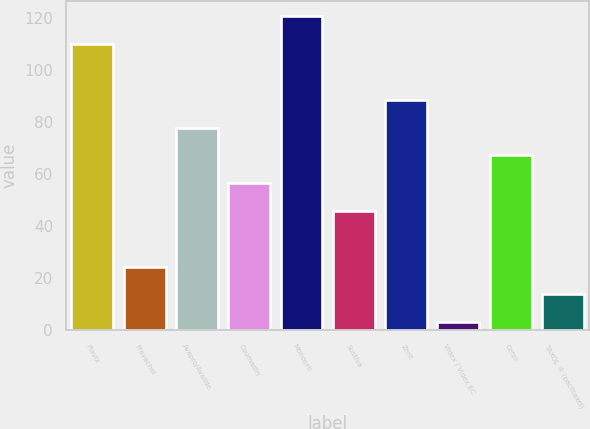Convert chart. <chart><loc_0><loc_0><loc_500><loc_500><bar_chart><fcel>Plavix<fcel>Pravachol<fcel>Avapro/Avalide<fcel>Coumadin<fcel>Monopril<fcel>Sustiva<fcel>Zerit<fcel>Videx / Videx EC<fcel>Cefzil<fcel>TAXOL ® (paclitaxel)<nl><fcel>110<fcel>24.4<fcel>77.9<fcel>56.5<fcel>120.7<fcel>45.8<fcel>88.6<fcel>3<fcel>67.2<fcel>13.7<nl></chart> 